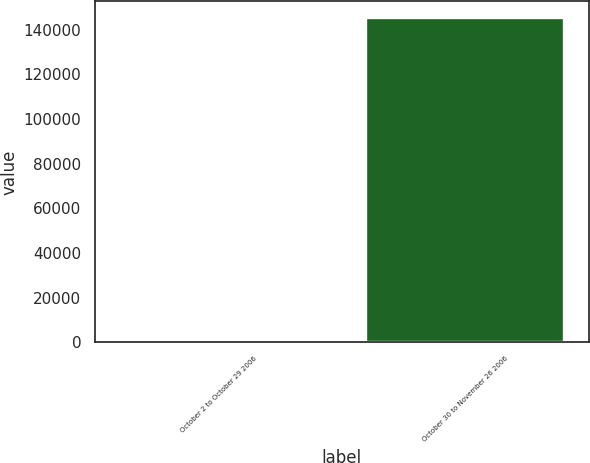Convert chart to OTSL. <chart><loc_0><loc_0><loc_500><loc_500><bar_chart><fcel>October 2 to October 29 2006<fcel>October 30 to November 26 2006<nl><fcel>182<fcel>145487<nl></chart> 